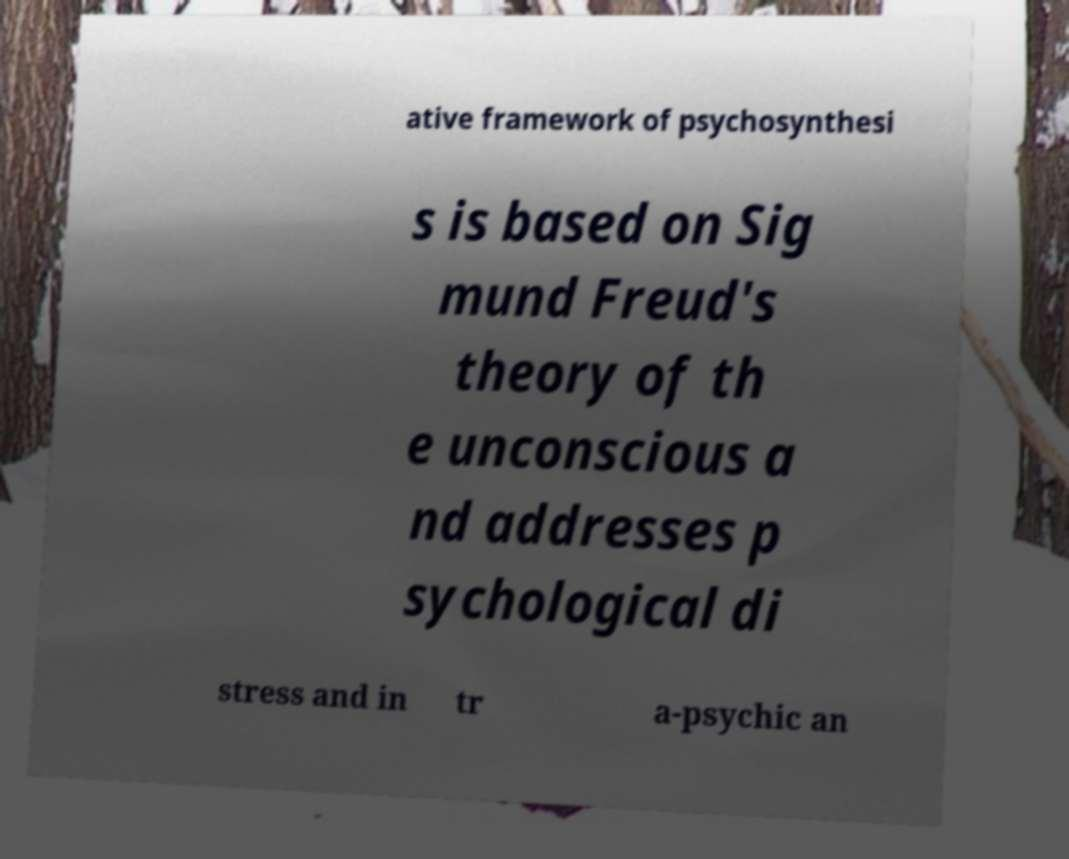For documentation purposes, I need the text within this image transcribed. Could you provide that? ative framework of psychosynthesi s is based on Sig mund Freud's theory of th e unconscious a nd addresses p sychological di stress and in tr a-psychic an 